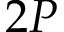<formula> <loc_0><loc_0><loc_500><loc_500>2 P</formula> 